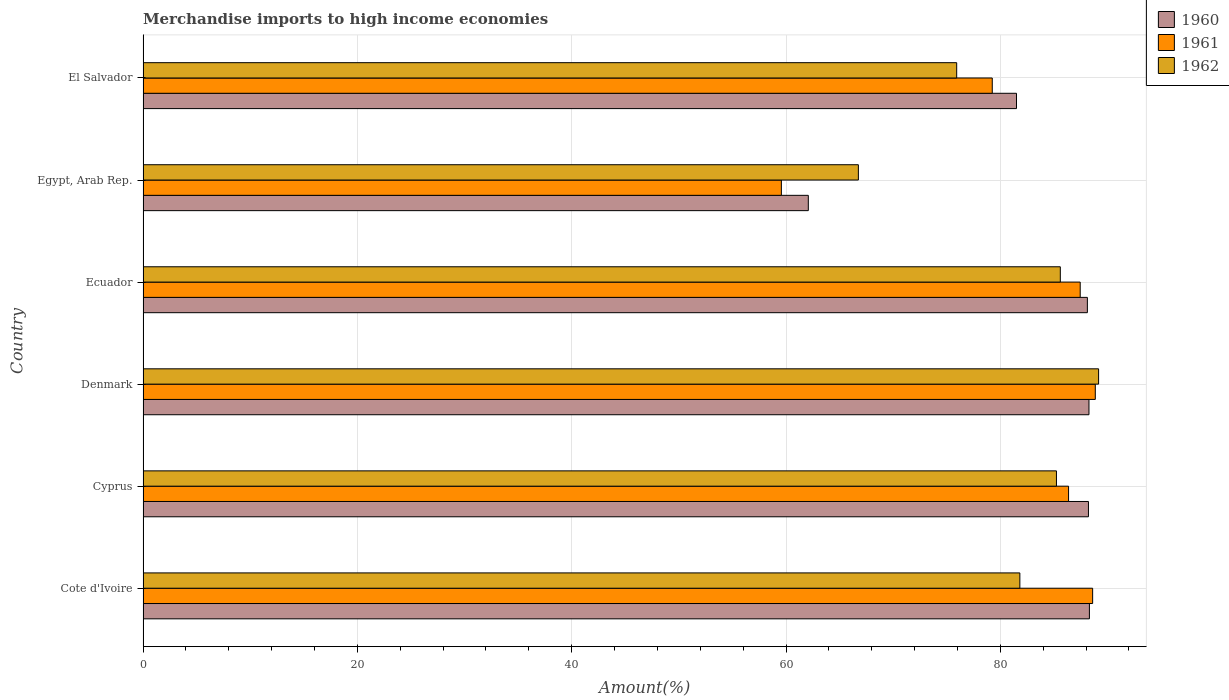How many different coloured bars are there?
Offer a terse response. 3. How many groups of bars are there?
Your answer should be very brief. 6. How many bars are there on the 4th tick from the top?
Your response must be concise. 3. What is the label of the 2nd group of bars from the top?
Your answer should be very brief. Egypt, Arab Rep. In how many cases, is the number of bars for a given country not equal to the number of legend labels?
Keep it short and to the point. 0. What is the percentage of amount earned from merchandise imports in 1962 in Egypt, Arab Rep.?
Your response must be concise. 66.75. Across all countries, what is the maximum percentage of amount earned from merchandise imports in 1962?
Provide a short and direct response. 89.17. Across all countries, what is the minimum percentage of amount earned from merchandise imports in 1961?
Your answer should be compact. 59.56. In which country was the percentage of amount earned from merchandise imports in 1961 minimum?
Make the answer very short. Egypt, Arab Rep. What is the total percentage of amount earned from merchandise imports in 1960 in the graph?
Your response must be concise. 496.5. What is the difference between the percentage of amount earned from merchandise imports in 1960 in Ecuador and that in El Salvador?
Offer a terse response. 6.61. What is the difference between the percentage of amount earned from merchandise imports in 1961 in El Salvador and the percentage of amount earned from merchandise imports in 1960 in Egypt, Arab Rep.?
Offer a terse response. 17.17. What is the average percentage of amount earned from merchandise imports in 1961 per country?
Provide a short and direct response. 81.68. What is the difference between the percentage of amount earned from merchandise imports in 1962 and percentage of amount earned from merchandise imports in 1961 in Egypt, Arab Rep.?
Offer a terse response. 7.19. In how many countries, is the percentage of amount earned from merchandise imports in 1961 greater than 44 %?
Your answer should be compact. 6. What is the ratio of the percentage of amount earned from merchandise imports in 1961 in Denmark to that in Ecuador?
Your answer should be very brief. 1.02. Is the difference between the percentage of amount earned from merchandise imports in 1962 in Cyprus and Egypt, Arab Rep. greater than the difference between the percentage of amount earned from merchandise imports in 1961 in Cyprus and Egypt, Arab Rep.?
Ensure brevity in your answer.  No. What is the difference between the highest and the second highest percentage of amount earned from merchandise imports in 1962?
Your response must be concise. 3.57. What is the difference between the highest and the lowest percentage of amount earned from merchandise imports in 1962?
Your answer should be compact. 22.42. In how many countries, is the percentage of amount earned from merchandise imports in 1961 greater than the average percentage of amount earned from merchandise imports in 1961 taken over all countries?
Give a very brief answer. 4. What does the 3rd bar from the top in Ecuador represents?
Offer a terse response. 1960. Are all the bars in the graph horizontal?
Offer a very short reply. Yes. Does the graph contain any zero values?
Offer a terse response. No. Does the graph contain grids?
Your answer should be compact. Yes. Where does the legend appear in the graph?
Your response must be concise. Top right. How many legend labels are there?
Your response must be concise. 3. What is the title of the graph?
Keep it short and to the point. Merchandise imports to high income economies. What is the label or title of the X-axis?
Provide a short and direct response. Amount(%). What is the Amount(%) in 1960 in Cote d'Ivoire?
Make the answer very short. 88.31. What is the Amount(%) in 1961 in Cote d'Ivoire?
Offer a very short reply. 88.61. What is the Amount(%) in 1962 in Cote d'Ivoire?
Offer a very short reply. 81.82. What is the Amount(%) in 1960 in Cyprus?
Your response must be concise. 88.22. What is the Amount(%) in 1961 in Cyprus?
Your answer should be very brief. 86.36. What is the Amount(%) of 1962 in Cyprus?
Your response must be concise. 85.23. What is the Amount(%) in 1960 in Denmark?
Your answer should be very brief. 88.27. What is the Amount(%) of 1961 in Denmark?
Offer a terse response. 88.86. What is the Amount(%) in 1962 in Denmark?
Offer a very short reply. 89.17. What is the Amount(%) in 1960 in Ecuador?
Provide a short and direct response. 88.12. What is the Amount(%) in 1961 in Ecuador?
Make the answer very short. 87.45. What is the Amount(%) of 1962 in Ecuador?
Offer a terse response. 85.59. What is the Amount(%) of 1960 in Egypt, Arab Rep.?
Ensure brevity in your answer.  62.08. What is the Amount(%) of 1961 in Egypt, Arab Rep.?
Provide a short and direct response. 59.56. What is the Amount(%) in 1962 in Egypt, Arab Rep.?
Provide a succinct answer. 66.75. What is the Amount(%) in 1960 in El Salvador?
Provide a short and direct response. 81.51. What is the Amount(%) in 1961 in El Salvador?
Your response must be concise. 79.24. What is the Amount(%) in 1962 in El Salvador?
Offer a very short reply. 75.92. Across all countries, what is the maximum Amount(%) in 1960?
Provide a short and direct response. 88.31. Across all countries, what is the maximum Amount(%) of 1961?
Provide a succinct answer. 88.86. Across all countries, what is the maximum Amount(%) in 1962?
Keep it short and to the point. 89.17. Across all countries, what is the minimum Amount(%) in 1960?
Keep it short and to the point. 62.08. Across all countries, what is the minimum Amount(%) in 1961?
Offer a terse response. 59.56. Across all countries, what is the minimum Amount(%) in 1962?
Keep it short and to the point. 66.75. What is the total Amount(%) in 1960 in the graph?
Your answer should be very brief. 496.5. What is the total Amount(%) of 1961 in the graph?
Provide a short and direct response. 490.09. What is the total Amount(%) of 1962 in the graph?
Ensure brevity in your answer.  484.48. What is the difference between the Amount(%) of 1960 in Cote d'Ivoire and that in Cyprus?
Offer a terse response. 0.09. What is the difference between the Amount(%) of 1961 in Cote d'Ivoire and that in Cyprus?
Keep it short and to the point. 2.25. What is the difference between the Amount(%) in 1962 in Cote d'Ivoire and that in Cyprus?
Provide a succinct answer. -3.41. What is the difference between the Amount(%) in 1960 in Cote d'Ivoire and that in Denmark?
Provide a succinct answer. 0.04. What is the difference between the Amount(%) of 1961 in Cote d'Ivoire and that in Denmark?
Your answer should be very brief. -0.25. What is the difference between the Amount(%) in 1962 in Cote d'Ivoire and that in Denmark?
Ensure brevity in your answer.  -7.35. What is the difference between the Amount(%) in 1960 in Cote d'Ivoire and that in Ecuador?
Provide a short and direct response. 0.19. What is the difference between the Amount(%) in 1961 in Cote d'Ivoire and that in Ecuador?
Make the answer very short. 1.16. What is the difference between the Amount(%) in 1962 in Cote d'Ivoire and that in Ecuador?
Your answer should be compact. -3.77. What is the difference between the Amount(%) of 1960 in Cote d'Ivoire and that in Egypt, Arab Rep.?
Your answer should be very brief. 26.23. What is the difference between the Amount(%) in 1961 in Cote d'Ivoire and that in Egypt, Arab Rep.?
Your answer should be compact. 29.05. What is the difference between the Amount(%) in 1962 in Cote d'Ivoire and that in Egypt, Arab Rep.?
Keep it short and to the point. 15.07. What is the difference between the Amount(%) of 1960 in Cote d'Ivoire and that in El Salvador?
Your answer should be compact. 6.8. What is the difference between the Amount(%) in 1961 in Cote d'Ivoire and that in El Salvador?
Make the answer very short. 9.37. What is the difference between the Amount(%) in 1962 in Cote d'Ivoire and that in El Salvador?
Your response must be concise. 5.9. What is the difference between the Amount(%) of 1960 in Cyprus and that in Denmark?
Offer a terse response. -0.05. What is the difference between the Amount(%) in 1961 in Cyprus and that in Denmark?
Give a very brief answer. -2.49. What is the difference between the Amount(%) in 1962 in Cyprus and that in Denmark?
Provide a succinct answer. -3.93. What is the difference between the Amount(%) in 1960 in Cyprus and that in Ecuador?
Your answer should be very brief. 0.1. What is the difference between the Amount(%) in 1961 in Cyprus and that in Ecuador?
Your response must be concise. -1.09. What is the difference between the Amount(%) in 1962 in Cyprus and that in Ecuador?
Offer a very short reply. -0.36. What is the difference between the Amount(%) of 1960 in Cyprus and that in Egypt, Arab Rep.?
Give a very brief answer. 26.14. What is the difference between the Amount(%) in 1961 in Cyprus and that in Egypt, Arab Rep.?
Give a very brief answer. 26.8. What is the difference between the Amount(%) of 1962 in Cyprus and that in Egypt, Arab Rep.?
Give a very brief answer. 18.48. What is the difference between the Amount(%) of 1960 in Cyprus and that in El Salvador?
Make the answer very short. 6.71. What is the difference between the Amount(%) in 1961 in Cyprus and that in El Salvador?
Provide a short and direct response. 7.12. What is the difference between the Amount(%) in 1962 in Cyprus and that in El Salvador?
Your response must be concise. 9.31. What is the difference between the Amount(%) in 1960 in Denmark and that in Ecuador?
Provide a short and direct response. 0.15. What is the difference between the Amount(%) of 1961 in Denmark and that in Ecuador?
Make the answer very short. 1.41. What is the difference between the Amount(%) in 1962 in Denmark and that in Ecuador?
Ensure brevity in your answer.  3.57. What is the difference between the Amount(%) in 1960 in Denmark and that in Egypt, Arab Rep.?
Ensure brevity in your answer.  26.19. What is the difference between the Amount(%) of 1961 in Denmark and that in Egypt, Arab Rep.?
Provide a short and direct response. 29.29. What is the difference between the Amount(%) of 1962 in Denmark and that in Egypt, Arab Rep.?
Provide a short and direct response. 22.42. What is the difference between the Amount(%) in 1960 in Denmark and that in El Salvador?
Provide a succinct answer. 6.76. What is the difference between the Amount(%) in 1961 in Denmark and that in El Salvador?
Offer a very short reply. 9.62. What is the difference between the Amount(%) in 1962 in Denmark and that in El Salvador?
Ensure brevity in your answer.  13.24. What is the difference between the Amount(%) of 1960 in Ecuador and that in Egypt, Arab Rep.?
Your answer should be compact. 26.04. What is the difference between the Amount(%) in 1961 in Ecuador and that in Egypt, Arab Rep.?
Provide a short and direct response. 27.89. What is the difference between the Amount(%) in 1962 in Ecuador and that in Egypt, Arab Rep.?
Ensure brevity in your answer.  18.84. What is the difference between the Amount(%) of 1960 in Ecuador and that in El Salvador?
Your answer should be very brief. 6.61. What is the difference between the Amount(%) of 1961 in Ecuador and that in El Salvador?
Provide a short and direct response. 8.21. What is the difference between the Amount(%) of 1962 in Ecuador and that in El Salvador?
Your answer should be very brief. 9.67. What is the difference between the Amount(%) in 1960 in Egypt, Arab Rep. and that in El Salvador?
Your response must be concise. -19.43. What is the difference between the Amount(%) of 1961 in Egypt, Arab Rep. and that in El Salvador?
Offer a very short reply. -19.68. What is the difference between the Amount(%) in 1962 in Egypt, Arab Rep. and that in El Salvador?
Your answer should be compact. -9.17. What is the difference between the Amount(%) in 1960 in Cote d'Ivoire and the Amount(%) in 1961 in Cyprus?
Your response must be concise. 1.95. What is the difference between the Amount(%) of 1960 in Cote d'Ivoire and the Amount(%) of 1962 in Cyprus?
Offer a very short reply. 3.08. What is the difference between the Amount(%) in 1961 in Cote d'Ivoire and the Amount(%) in 1962 in Cyprus?
Provide a short and direct response. 3.38. What is the difference between the Amount(%) in 1960 in Cote d'Ivoire and the Amount(%) in 1961 in Denmark?
Your answer should be compact. -0.55. What is the difference between the Amount(%) of 1960 in Cote d'Ivoire and the Amount(%) of 1962 in Denmark?
Keep it short and to the point. -0.86. What is the difference between the Amount(%) in 1961 in Cote d'Ivoire and the Amount(%) in 1962 in Denmark?
Ensure brevity in your answer.  -0.56. What is the difference between the Amount(%) of 1960 in Cote d'Ivoire and the Amount(%) of 1961 in Ecuador?
Offer a terse response. 0.86. What is the difference between the Amount(%) of 1960 in Cote d'Ivoire and the Amount(%) of 1962 in Ecuador?
Provide a succinct answer. 2.72. What is the difference between the Amount(%) of 1961 in Cote d'Ivoire and the Amount(%) of 1962 in Ecuador?
Your response must be concise. 3.02. What is the difference between the Amount(%) in 1960 in Cote d'Ivoire and the Amount(%) in 1961 in Egypt, Arab Rep.?
Ensure brevity in your answer.  28.75. What is the difference between the Amount(%) of 1960 in Cote d'Ivoire and the Amount(%) of 1962 in Egypt, Arab Rep.?
Make the answer very short. 21.56. What is the difference between the Amount(%) of 1961 in Cote d'Ivoire and the Amount(%) of 1962 in Egypt, Arab Rep.?
Give a very brief answer. 21.86. What is the difference between the Amount(%) of 1960 in Cote d'Ivoire and the Amount(%) of 1961 in El Salvador?
Give a very brief answer. 9.07. What is the difference between the Amount(%) of 1960 in Cote d'Ivoire and the Amount(%) of 1962 in El Salvador?
Your answer should be very brief. 12.39. What is the difference between the Amount(%) in 1961 in Cote d'Ivoire and the Amount(%) in 1962 in El Salvador?
Your answer should be compact. 12.69. What is the difference between the Amount(%) in 1960 in Cyprus and the Amount(%) in 1961 in Denmark?
Ensure brevity in your answer.  -0.64. What is the difference between the Amount(%) in 1960 in Cyprus and the Amount(%) in 1962 in Denmark?
Provide a succinct answer. -0.95. What is the difference between the Amount(%) of 1961 in Cyprus and the Amount(%) of 1962 in Denmark?
Provide a short and direct response. -2.8. What is the difference between the Amount(%) of 1960 in Cyprus and the Amount(%) of 1961 in Ecuador?
Ensure brevity in your answer.  0.77. What is the difference between the Amount(%) in 1960 in Cyprus and the Amount(%) in 1962 in Ecuador?
Offer a terse response. 2.63. What is the difference between the Amount(%) of 1961 in Cyprus and the Amount(%) of 1962 in Ecuador?
Offer a very short reply. 0.77. What is the difference between the Amount(%) of 1960 in Cyprus and the Amount(%) of 1961 in Egypt, Arab Rep.?
Give a very brief answer. 28.66. What is the difference between the Amount(%) in 1960 in Cyprus and the Amount(%) in 1962 in Egypt, Arab Rep.?
Offer a terse response. 21.47. What is the difference between the Amount(%) of 1961 in Cyprus and the Amount(%) of 1962 in Egypt, Arab Rep.?
Offer a very short reply. 19.61. What is the difference between the Amount(%) of 1960 in Cyprus and the Amount(%) of 1961 in El Salvador?
Your response must be concise. 8.98. What is the difference between the Amount(%) in 1960 in Cyprus and the Amount(%) in 1962 in El Salvador?
Ensure brevity in your answer.  12.3. What is the difference between the Amount(%) of 1961 in Cyprus and the Amount(%) of 1962 in El Salvador?
Provide a short and direct response. 10.44. What is the difference between the Amount(%) of 1960 in Denmark and the Amount(%) of 1961 in Ecuador?
Provide a short and direct response. 0.82. What is the difference between the Amount(%) in 1960 in Denmark and the Amount(%) in 1962 in Ecuador?
Keep it short and to the point. 2.67. What is the difference between the Amount(%) in 1961 in Denmark and the Amount(%) in 1962 in Ecuador?
Ensure brevity in your answer.  3.27. What is the difference between the Amount(%) in 1960 in Denmark and the Amount(%) in 1961 in Egypt, Arab Rep.?
Your answer should be compact. 28.7. What is the difference between the Amount(%) of 1960 in Denmark and the Amount(%) of 1962 in Egypt, Arab Rep.?
Give a very brief answer. 21.52. What is the difference between the Amount(%) of 1961 in Denmark and the Amount(%) of 1962 in Egypt, Arab Rep.?
Keep it short and to the point. 22.11. What is the difference between the Amount(%) of 1960 in Denmark and the Amount(%) of 1961 in El Salvador?
Offer a very short reply. 9.02. What is the difference between the Amount(%) of 1960 in Denmark and the Amount(%) of 1962 in El Salvador?
Your response must be concise. 12.34. What is the difference between the Amount(%) of 1961 in Denmark and the Amount(%) of 1962 in El Salvador?
Give a very brief answer. 12.94. What is the difference between the Amount(%) in 1960 in Ecuador and the Amount(%) in 1961 in Egypt, Arab Rep.?
Give a very brief answer. 28.56. What is the difference between the Amount(%) in 1960 in Ecuador and the Amount(%) in 1962 in Egypt, Arab Rep.?
Provide a succinct answer. 21.37. What is the difference between the Amount(%) of 1961 in Ecuador and the Amount(%) of 1962 in Egypt, Arab Rep.?
Your answer should be very brief. 20.7. What is the difference between the Amount(%) of 1960 in Ecuador and the Amount(%) of 1961 in El Salvador?
Give a very brief answer. 8.88. What is the difference between the Amount(%) in 1960 in Ecuador and the Amount(%) in 1962 in El Salvador?
Offer a very short reply. 12.2. What is the difference between the Amount(%) of 1961 in Ecuador and the Amount(%) of 1962 in El Salvador?
Offer a terse response. 11.53. What is the difference between the Amount(%) in 1960 in Egypt, Arab Rep. and the Amount(%) in 1961 in El Salvador?
Give a very brief answer. -17.17. What is the difference between the Amount(%) in 1960 in Egypt, Arab Rep. and the Amount(%) in 1962 in El Salvador?
Your answer should be compact. -13.84. What is the difference between the Amount(%) of 1961 in Egypt, Arab Rep. and the Amount(%) of 1962 in El Salvador?
Provide a succinct answer. -16.36. What is the average Amount(%) in 1960 per country?
Provide a succinct answer. 82.75. What is the average Amount(%) in 1961 per country?
Offer a terse response. 81.68. What is the average Amount(%) in 1962 per country?
Provide a short and direct response. 80.75. What is the difference between the Amount(%) of 1960 and Amount(%) of 1961 in Cote d'Ivoire?
Ensure brevity in your answer.  -0.3. What is the difference between the Amount(%) in 1960 and Amount(%) in 1962 in Cote d'Ivoire?
Your answer should be very brief. 6.49. What is the difference between the Amount(%) in 1961 and Amount(%) in 1962 in Cote d'Ivoire?
Keep it short and to the point. 6.79. What is the difference between the Amount(%) in 1960 and Amount(%) in 1961 in Cyprus?
Provide a short and direct response. 1.86. What is the difference between the Amount(%) in 1960 and Amount(%) in 1962 in Cyprus?
Your answer should be very brief. 2.99. What is the difference between the Amount(%) of 1961 and Amount(%) of 1962 in Cyprus?
Provide a succinct answer. 1.13. What is the difference between the Amount(%) in 1960 and Amount(%) in 1961 in Denmark?
Your answer should be compact. -0.59. What is the difference between the Amount(%) in 1960 and Amount(%) in 1962 in Denmark?
Provide a short and direct response. -0.9. What is the difference between the Amount(%) of 1961 and Amount(%) of 1962 in Denmark?
Make the answer very short. -0.31. What is the difference between the Amount(%) in 1960 and Amount(%) in 1961 in Ecuador?
Ensure brevity in your answer.  0.67. What is the difference between the Amount(%) in 1960 and Amount(%) in 1962 in Ecuador?
Provide a short and direct response. 2.53. What is the difference between the Amount(%) in 1961 and Amount(%) in 1962 in Ecuador?
Provide a short and direct response. 1.86. What is the difference between the Amount(%) in 1960 and Amount(%) in 1961 in Egypt, Arab Rep.?
Your response must be concise. 2.51. What is the difference between the Amount(%) of 1960 and Amount(%) of 1962 in Egypt, Arab Rep.?
Offer a very short reply. -4.67. What is the difference between the Amount(%) of 1961 and Amount(%) of 1962 in Egypt, Arab Rep.?
Make the answer very short. -7.19. What is the difference between the Amount(%) of 1960 and Amount(%) of 1961 in El Salvador?
Provide a succinct answer. 2.26. What is the difference between the Amount(%) of 1960 and Amount(%) of 1962 in El Salvador?
Keep it short and to the point. 5.58. What is the difference between the Amount(%) of 1961 and Amount(%) of 1962 in El Salvador?
Provide a short and direct response. 3.32. What is the ratio of the Amount(%) in 1961 in Cote d'Ivoire to that in Cyprus?
Your answer should be very brief. 1.03. What is the ratio of the Amount(%) of 1962 in Cote d'Ivoire to that in Cyprus?
Ensure brevity in your answer.  0.96. What is the ratio of the Amount(%) in 1961 in Cote d'Ivoire to that in Denmark?
Your response must be concise. 1. What is the ratio of the Amount(%) of 1962 in Cote d'Ivoire to that in Denmark?
Make the answer very short. 0.92. What is the ratio of the Amount(%) of 1961 in Cote d'Ivoire to that in Ecuador?
Give a very brief answer. 1.01. What is the ratio of the Amount(%) of 1962 in Cote d'Ivoire to that in Ecuador?
Provide a short and direct response. 0.96. What is the ratio of the Amount(%) of 1960 in Cote d'Ivoire to that in Egypt, Arab Rep.?
Ensure brevity in your answer.  1.42. What is the ratio of the Amount(%) in 1961 in Cote d'Ivoire to that in Egypt, Arab Rep.?
Make the answer very short. 1.49. What is the ratio of the Amount(%) in 1962 in Cote d'Ivoire to that in Egypt, Arab Rep.?
Provide a succinct answer. 1.23. What is the ratio of the Amount(%) of 1960 in Cote d'Ivoire to that in El Salvador?
Your response must be concise. 1.08. What is the ratio of the Amount(%) of 1961 in Cote d'Ivoire to that in El Salvador?
Your answer should be compact. 1.12. What is the ratio of the Amount(%) of 1962 in Cote d'Ivoire to that in El Salvador?
Ensure brevity in your answer.  1.08. What is the ratio of the Amount(%) of 1960 in Cyprus to that in Denmark?
Ensure brevity in your answer.  1. What is the ratio of the Amount(%) of 1961 in Cyprus to that in Denmark?
Ensure brevity in your answer.  0.97. What is the ratio of the Amount(%) in 1962 in Cyprus to that in Denmark?
Your response must be concise. 0.96. What is the ratio of the Amount(%) in 1960 in Cyprus to that in Ecuador?
Make the answer very short. 1. What is the ratio of the Amount(%) of 1961 in Cyprus to that in Ecuador?
Ensure brevity in your answer.  0.99. What is the ratio of the Amount(%) of 1960 in Cyprus to that in Egypt, Arab Rep.?
Keep it short and to the point. 1.42. What is the ratio of the Amount(%) in 1961 in Cyprus to that in Egypt, Arab Rep.?
Your response must be concise. 1.45. What is the ratio of the Amount(%) in 1962 in Cyprus to that in Egypt, Arab Rep.?
Make the answer very short. 1.28. What is the ratio of the Amount(%) in 1960 in Cyprus to that in El Salvador?
Offer a terse response. 1.08. What is the ratio of the Amount(%) of 1961 in Cyprus to that in El Salvador?
Your answer should be very brief. 1.09. What is the ratio of the Amount(%) in 1962 in Cyprus to that in El Salvador?
Your answer should be very brief. 1.12. What is the ratio of the Amount(%) of 1960 in Denmark to that in Ecuador?
Your response must be concise. 1. What is the ratio of the Amount(%) of 1961 in Denmark to that in Ecuador?
Your answer should be compact. 1.02. What is the ratio of the Amount(%) in 1962 in Denmark to that in Ecuador?
Your answer should be compact. 1.04. What is the ratio of the Amount(%) of 1960 in Denmark to that in Egypt, Arab Rep.?
Make the answer very short. 1.42. What is the ratio of the Amount(%) in 1961 in Denmark to that in Egypt, Arab Rep.?
Ensure brevity in your answer.  1.49. What is the ratio of the Amount(%) in 1962 in Denmark to that in Egypt, Arab Rep.?
Keep it short and to the point. 1.34. What is the ratio of the Amount(%) of 1960 in Denmark to that in El Salvador?
Your answer should be compact. 1.08. What is the ratio of the Amount(%) of 1961 in Denmark to that in El Salvador?
Keep it short and to the point. 1.12. What is the ratio of the Amount(%) in 1962 in Denmark to that in El Salvador?
Your response must be concise. 1.17. What is the ratio of the Amount(%) of 1960 in Ecuador to that in Egypt, Arab Rep.?
Provide a succinct answer. 1.42. What is the ratio of the Amount(%) in 1961 in Ecuador to that in Egypt, Arab Rep.?
Give a very brief answer. 1.47. What is the ratio of the Amount(%) in 1962 in Ecuador to that in Egypt, Arab Rep.?
Provide a short and direct response. 1.28. What is the ratio of the Amount(%) of 1960 in Ecuador to that in El Salvador?
Your response must be concise. 1.08. What is the ratio of the Amount(%) in 1961 in Ecuador to that in El Salvador?
Provide a short and direct response. 1.1. What is the ratio of the Amount(%) of 1962 in Ecuador to that in El Salvador?
Your answer should be very brief. 1.13. What is the ratio of the Amount(%) in 1960 in Egypt, Arab Rep. to that in El Salvador?
Ensure brevity in your answer.  0.76. What is the ratio of the Amount(%) of 1961 in Egypt, Arab Rep. to that in El Salvador?
Your answer should be compact. 0.75. What is the ratio of the Amount(%) in 1962 in Egypt, Arab Rep. to that in El Salvador?
Your answer should be compact. 0.88. What is the difference between the highest and the second highest Amount(%) of 1960?
Keep it short and to the point. 0.04. What is the difference between the highest and the second highest Amount(%) in 1961?
Provide a succinct answer. 0.25. What is the difference between the highest and the second highest Amount(%) in 1962?
Provide a short and direct response. 3.57. What is the difference between the highest and the lowest Amount(%) in 1960?
Make the answer very short. 26.23. What is the difference between the highest and the lowest Amount(%) in 1961?
Ensure brevity in your answer.  29.29. What is the difference between the highest and the lowest Amount(%) in 1962?
Your response must be concise. 22.42. 